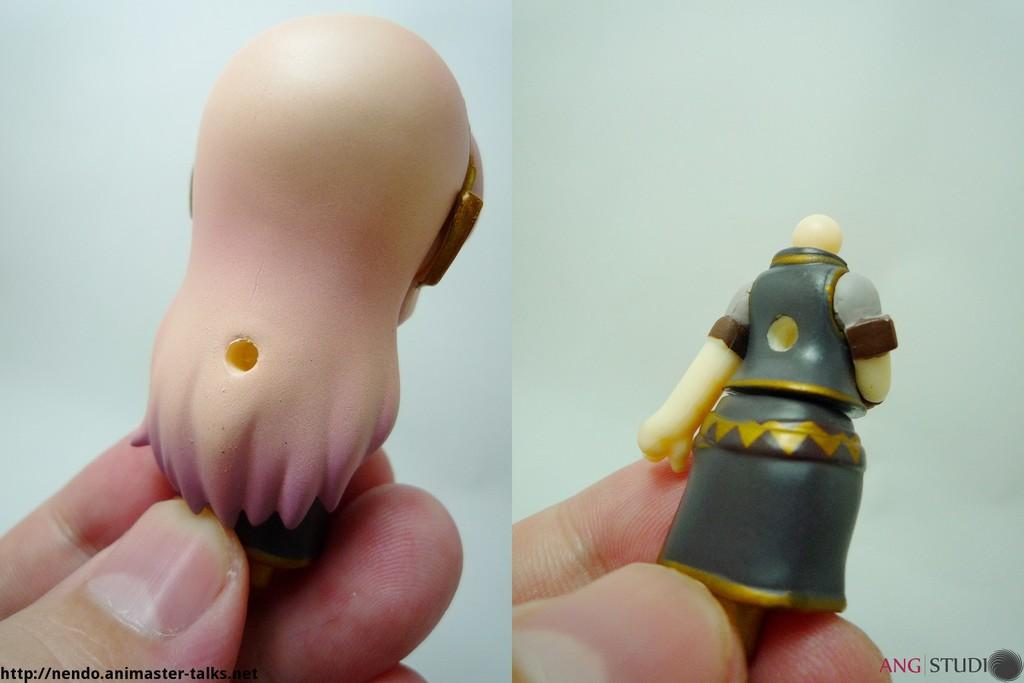What is happening in the image involving the hands of two persons? There are two persons' hands holding toys in the image. What can be found at the bottom of the image? There is text at the bottom of the image. What type of jewel is being held by the persons in the image? There is no jewel present in the image; it features two persons' hands holding toys. How many slaves are visible in the image? There is no reference to any slaves in the image; it only shows two persons' hands holding toys and text at the bottom. 